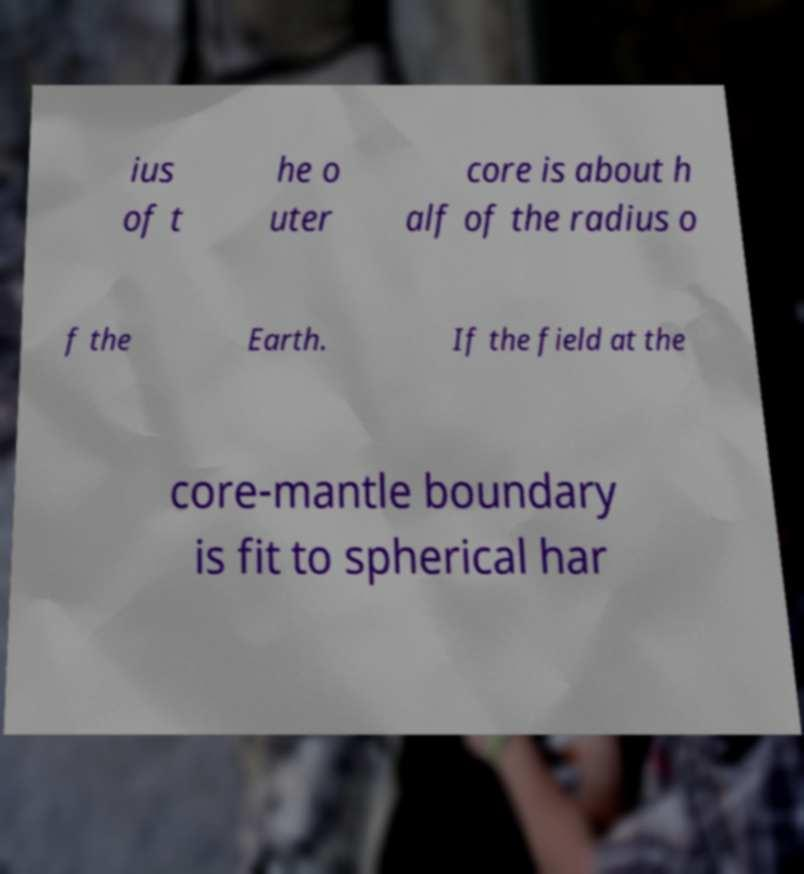There's text embedded in this image that I need extracted. Can you transcribe it verbatim? ius of t he o uter core is about h alf of the radius o f the Earth. If the field at the core-mantle boundary is fit to spherical har 